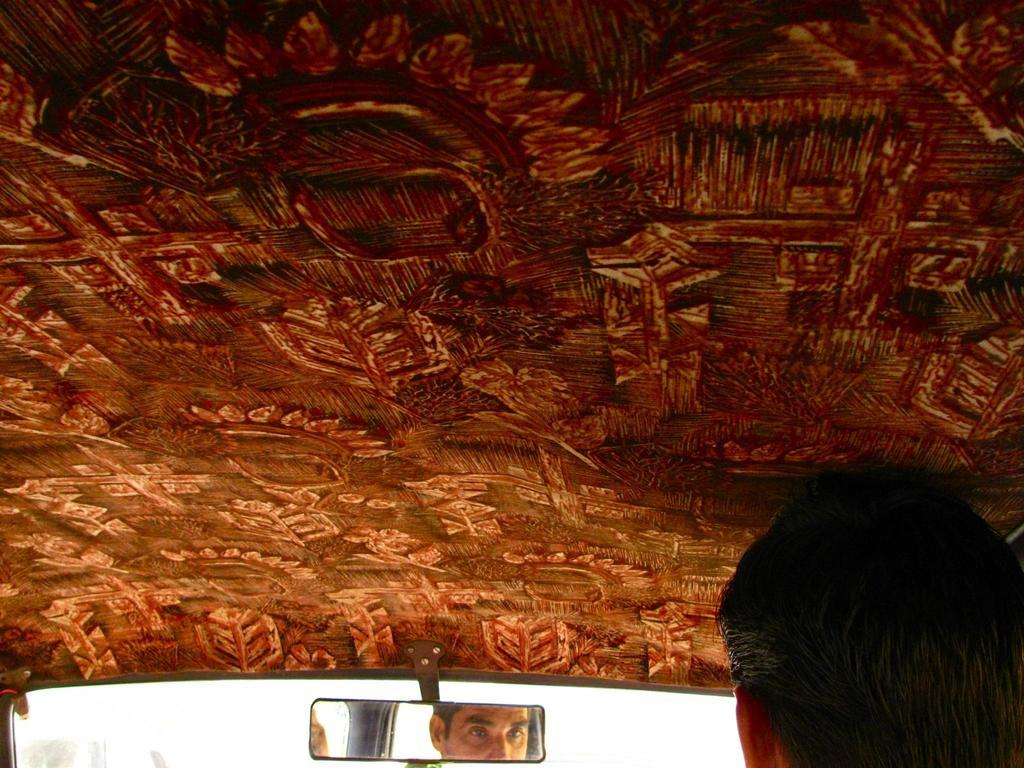Who is present in the image? There is a man in the image. Where is the man located? The man is sitting inside a van. Can you describe any other objects or features in the image? There is a mirror at the bottom of the image. What type of jewel is the owl carrying in its pocket in the image? There is no owl or jewel present in the image. The image only features a man sitting inside a van and a mirror at the bottom. 